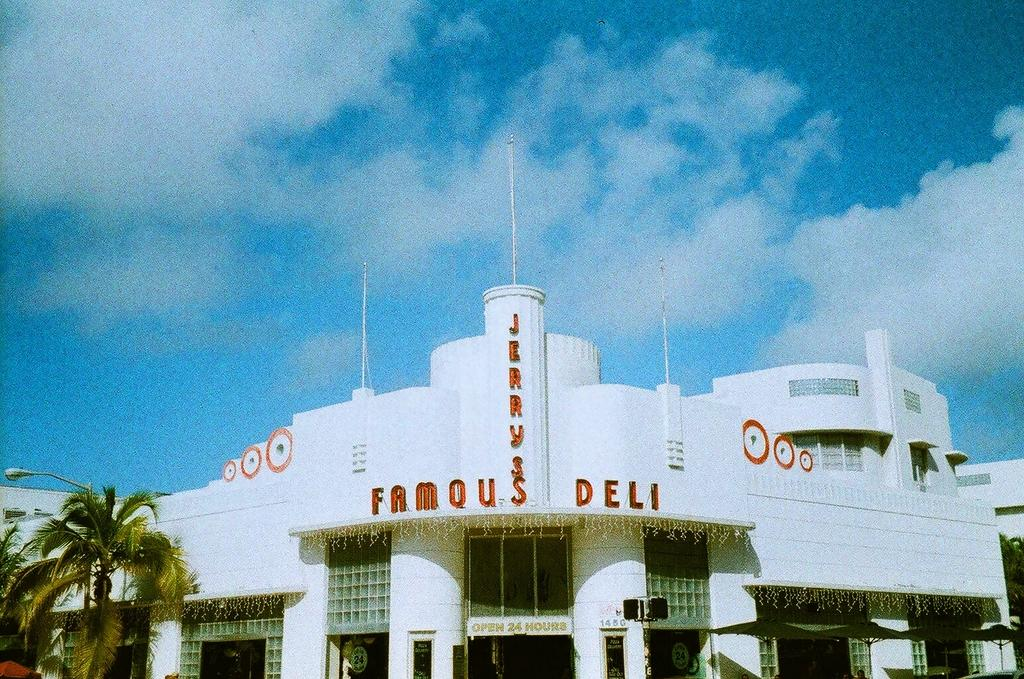<image>
Share a concise interpretation of the image provided. A wide angle shot of Jerry's Famous Deli on a sunny day. 